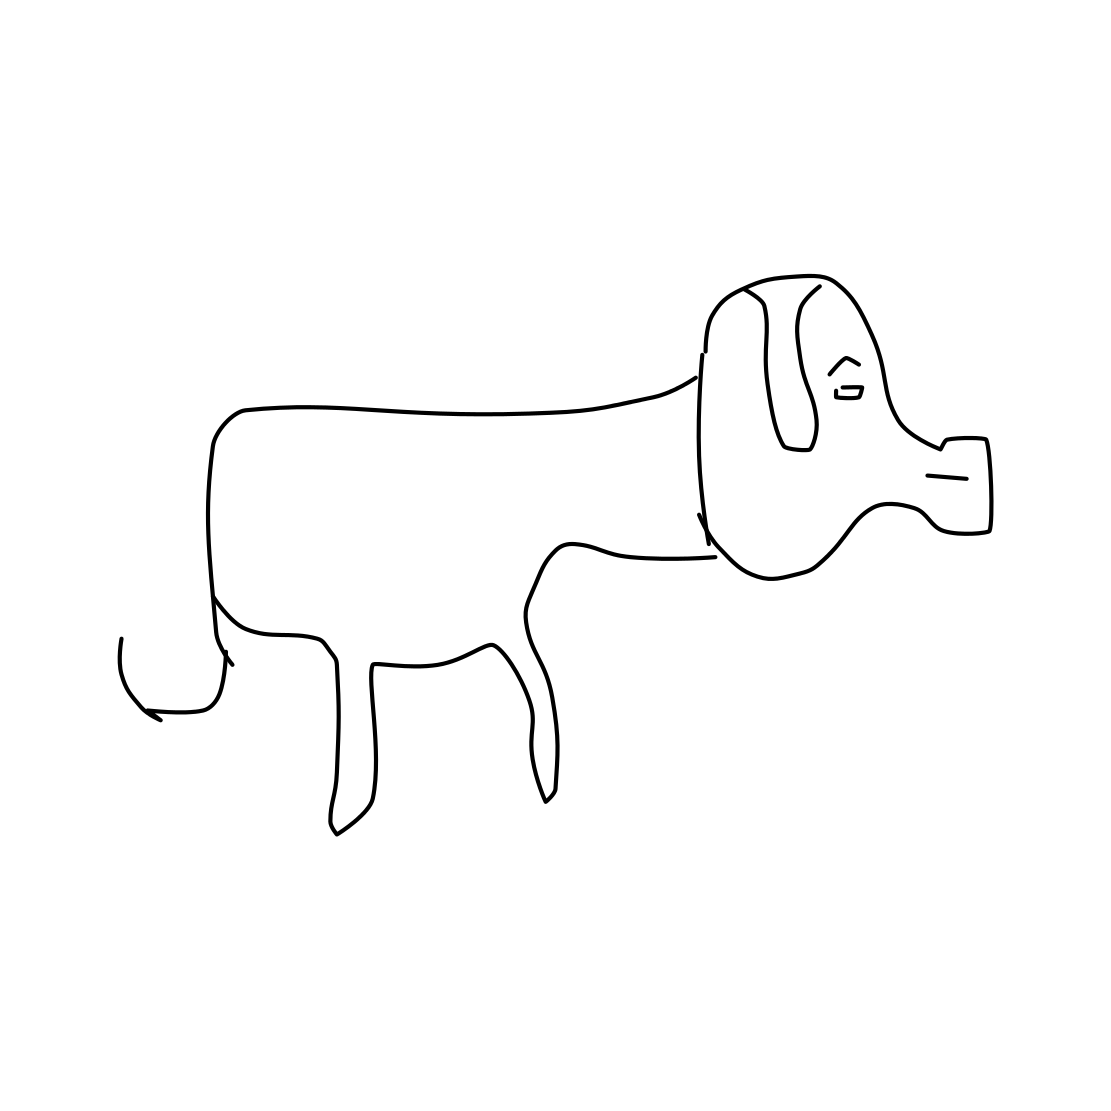What do you think the mood of this dog is? The drawing is quite basic, but the dog's posture and facial expression, with ears perked up and an even line representing the mouth, might suggest a neutral or contented mood. 